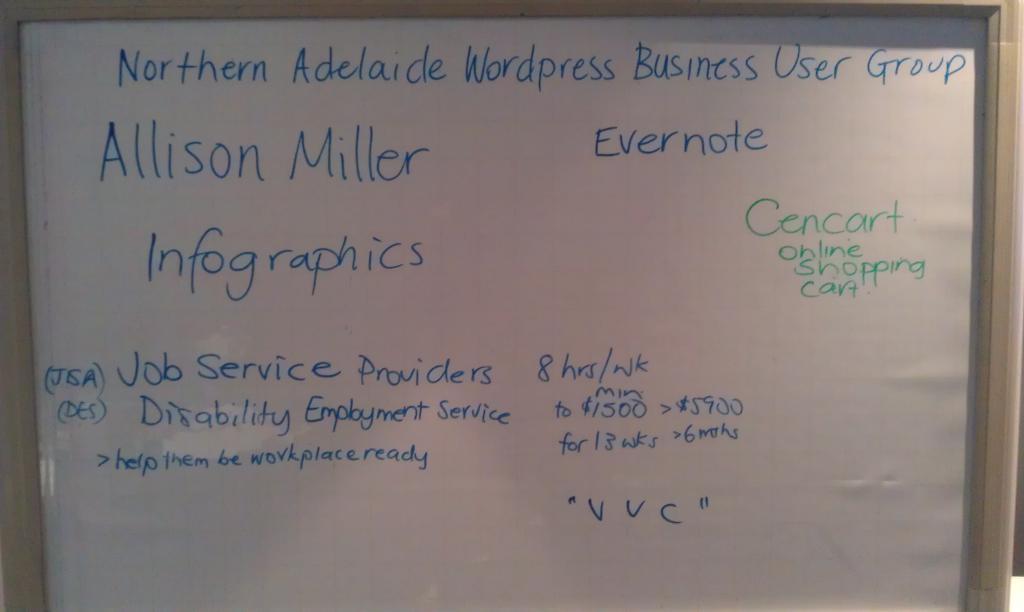Describe this image in one or two sentences. As we can see in the image there is a white color board. On board there is something written. 